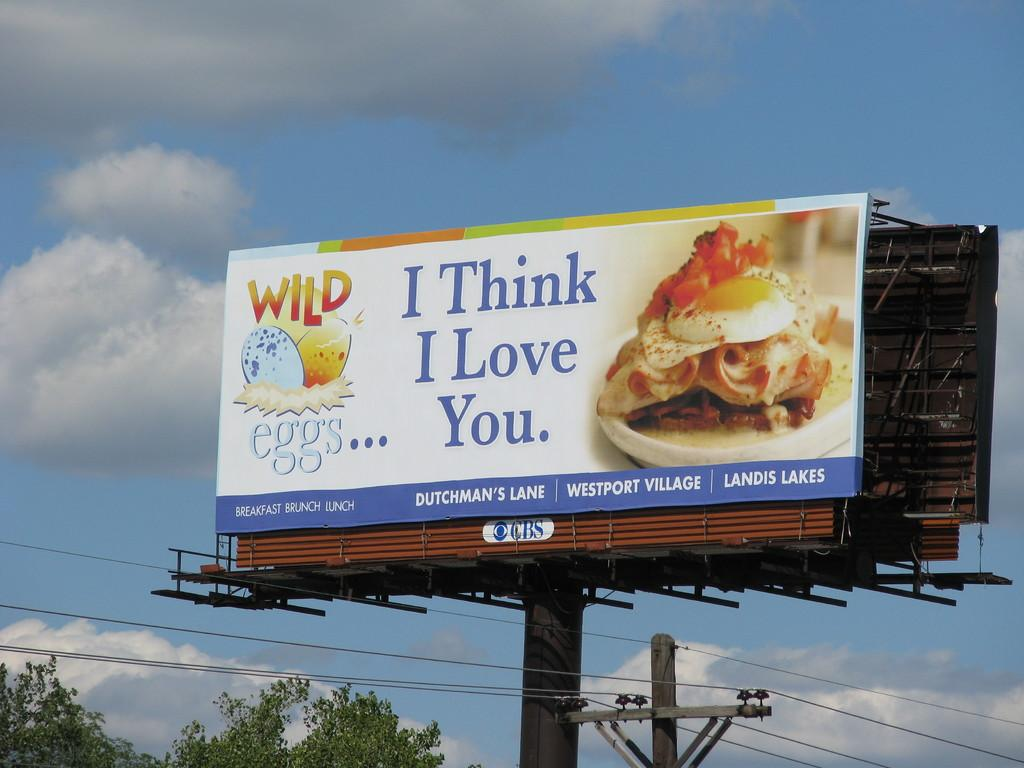<image>
Write a terse but informative summary of the picture. A sign for Wildeggs in Westport Village says "I think I love you" next to a picture of an egg sandwhich\ 